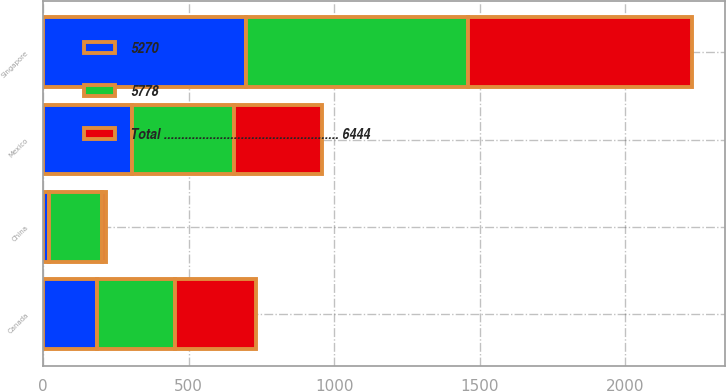Convert chart to OTSL. <chart><loc_0><loc_0><loc_500><loc_500><stacked_bar_chart><ecel><fcel>Singapore<fcel>Canada<fcel>Mexico<fcel>China<nl><fcel>5778<fcel>762<fcel>266<fcel>349<fcel>182<nl><fcel>Total .................................................. 6444<fcel>771<fcel>279<fcel>303<fcel>14<nl><fcel>5270<fcel>696<fcel>187<fcel>306<fcel>20<nl></chart> 